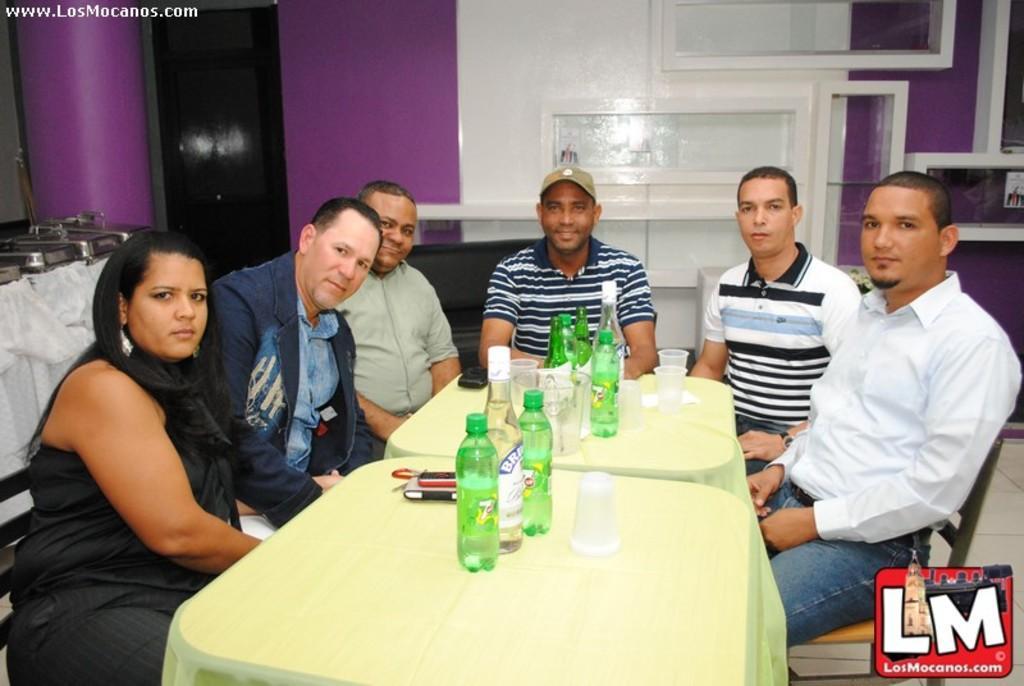In one or two sentences, can you explain what this image depicts? In this picture we can see group of people sitting on chair in middle person is smiling wore cap and in front of them we have table and on table we can see bottles, glass, mobile, tissue paper and in the background we can see wall, pillar. 